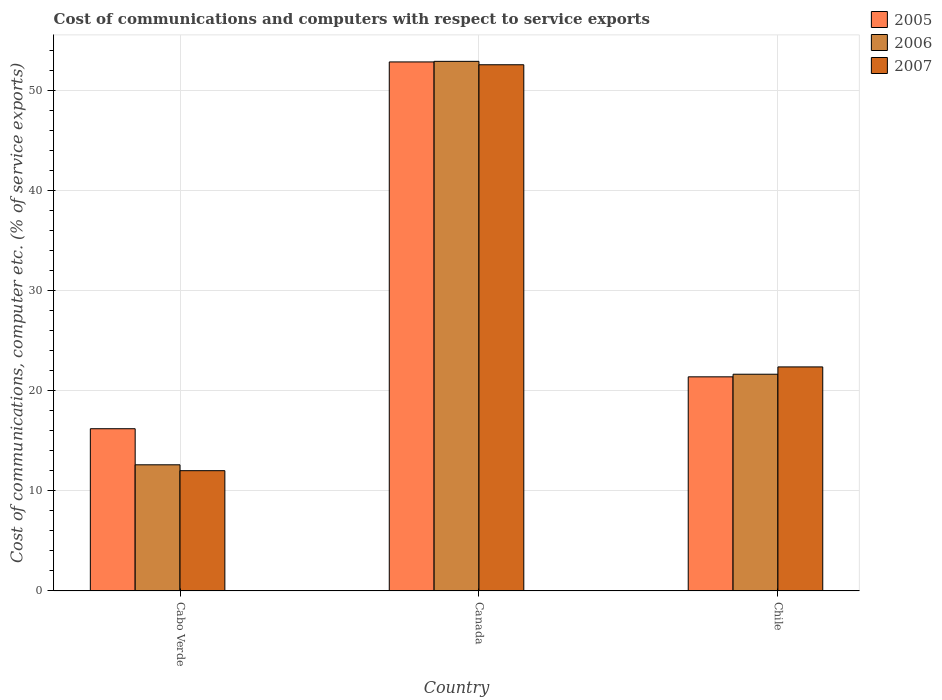How many bars are there on the 2nd tick from the left?
Provide a short and direct response. 3. How many bars are there on the 2nd tick from the right?
Offer a very short reply. 3. What is the cost of communications and computers in 2006 in Cabo Verde?
Provide a succinct answer. 12.61. Across all countries, what is the maximum cost of communications and computers in 2007?
Make the answer very short. 52.62. Across all countries, what is the minimum cost of communications and computers in 2006?
Keep it short and to the point. 12.61. In which country was the cost of communications and computers in 2005 minimum?
Your response must be concise. Cabo Verde. What is the total cost of communications and computers in 2005 in the graph?
Your answer should be compact. 90.53. What is the difference between the cost of communications and computers in 2005 in Cabo Verde and that in Chile?
Make the answer very short. -5.19. What is the difference between the cost of communications and computers in 2006 in Cabo Verde and the cost of communications and computers in 2005 in Canada?
Offer a very short reply. -40.29. What is the average cost of communications and computers in 2007 per country?
Ensure brevity in your answer.  29.01. What is the difference between the cost of communications and computers of/in 2005 and cost of communications and computers of/in 2006 in Chile?
Offer a very short reply. -0.26. What is the ratio of the cost of communications and computers in 2006 in Cabo Verde to that in Canada?
Ensure brevity in your answer.  0.24. Is the cost of communications and computers in 2005 in Cabo Verde less than that in Chile?
Ensure brevity in your answer.  Yes. Is the difference between the cost of communications and computers in 2005 in Cabo Verde and Canada greater than the difference between the cost of communications and computers in 2006 in Cabo Verde and Canada?
Offer a terse response. Yes. What is the difference between the highest and the second highest cost of communications and computers in 2007?
Your answer should be very brief. 40.59. What is the difference between the highest and the lowest cost of communications and computers in 2005?
Ensure brevity in your answer.  36.68. In how many countries, is the cost of communications and computers in 2005 greater than the average cost of communications and computers in 2005 taken over all countries?
Provide a succinct answer. 1. Is the sum of the cost of communications and computers in 2005 in Canada and Chile greater than the maximum cost of communications and computers in 2007 across all countries?
Your answer should be very brief. Yes. What does the 3rd bar from the left in Cabo Verde represents?
Give a very brief answer. 2007. What does the 1st bar from the right in Cabo Verde represents?
Offer a terse response. 2007. How many bars are there?
Provide a short and direct response. 9. What is the difference between two consecutive major ticks on the Y-axis?
Ensure brevity in your answer.  10. Where does the legend appear in the graph?
Make the answer very short. Top right. What is the title of the graph?
Give a very brief answer. Cost of communications and computers with respect to service exports. What is the label or title of the X-axis?
Your answer should be very brief. Country. What is the label or title of the Y-axis?
Your answer should be compact. Cost of communications, computer etc. (% of service exports). What is the Cost of communications, computer etc. (% of service exports) of 2005 in Cabo Verde?
Your answer should be compact. 16.22. What is the Cost of communications, computer etc. (% of service exports) in 2006 in Cabo Verde?
Give a very brief answer. 12.61. What is the Cost of communications, computer etc. (% of service exports) in 2007 in Cabo Verde?
Offer a very short reply. 12.02. What is the Cost of communications, computer etc. (% of service exports) in 2005 in Canada?
Offer a very short reply. 52.9. What is the Cost of communications, computer etc. (% of service exports) in 2006 in Canada?
Keep it short and to the point. 52.96. What is the Cost of communications, computer etc. (% of service exports) of 2007 in Canada?
Your answer should be very brief. 52.62. What is the Cost of communications, computer etc. (% of service exports) of 2005 in Chile?
Give a very brief answer. 21.41. What is the Cost of communications, computer etc. (% of service exports) of 2006 in Chile?
Offer a very short reply. 21.67. What is the Cost of communications, computer etc. (% of service exports) in 2007 in Chile?
Offer a very short reply. 22.4. Across all countries, what is the maximum Cost of communications, computer etc. (% of service exports) of 2005?
Provide a short and direct response. 52.9. Across all countries, what is the maximum Cost of communications, computer etc. (% of service exports) of 2006?
Provide a short and direct response. 52.96. Across all countries, what is the maximum Cost of communications, computer etc. (% of service exports) of 2007?
Keep it short and to the point. 52.62. Across all countries, what is the minimum Cost of communications, computer etc. (% of service exports) in 2005?
Keep it short and to the point. 16.22. Across all countries, what is the minimum Cost of communications, computer etc. (% of service exports) of 2006?
Your answer should be compact. 12.61. Across all countries, what is the minimum Cost of communications, computer etc. (% of service exports) of 2007?
Offer a very short reply. 12.02. What is the total Cost of communications, computer etc. (% of service exports) in 2005 in the graph?
Keep it short and to the point. 90.53. What is the total Cost of communications, computer etc. (% of service exports) of 2006 in the graph?
Offer a very short reply. 87.24. What is the total Cost of communications, computer etc. (% of service exports) of 2007 in the graph?
Make the answer very short. 87.04. What is the difference between the Cost of communications, computer etc. (% of service exports) of 2005 in Cabo Verde and that in Canada?
Your response must be concise. -36.68. What is the difference between the Cost of communications, computer etc. (% of service exports) of 2006 in Cabo Verde and that in Canada?
Offer a very short reply. -40.35. What is the difference between the Cost of communications, computer etc. (% of service exports) of 2007 in Cabo Verde and that in Canada?
Your answer should be very brief. -40.59. What is the difference between the Cost of communications, computer etc. (% of service exports) of 2005 in Cabo Verde and that in Chile?
Make the answer very short. -5.19. What is the difference between the Cost of communications, computer etc. (% of service exports) in 2006 in Cabo Verde and that in Chile?
Make the answer very short. -9.06. What is the difference between the Cost of communications, computer etc. (% of service exports) in 2007 in Cabo Verde and that in Chile?
Provide a short and direct response. -10.38. What is the difference between the Cost of communications, computer etc. (% of service exports) of 2005 in Canada and that in Chile?
Your answer should be compact. 31.49. What is the difference between the Cost of communications, computer etc. (% of service exports) in 2006 in Canada and that in Chile?
Ensure brevity in your answer.  31.29. What is the difference between the Cost of communications, computer etc. (% of service exports) of 2007 in Canada and that in Chile?
Your response must be concise. 30.22. What is the difference between the Cost of communications, computer etc. (% of service exports) of 2005 in Cabo Verde and the Cost of communications, computer etc. (% of service exports) of 2006 in Canada?
Provide a short and direct response. -36.74. What is the difference between the Cost of communications, computer etc. (% of service exports) in 2005 in Cabo Verde and the Cost of communications, computer etc. (% of service exports) in 2007 in Canada?
Offer a terse response. -36.4. What is the difference between the Cost of communications, computer etc. (% of service exports) in 2006 in Cabo Verde and the Cost of communications, computer etc. (% of service exports) in 2007 in Canada?
Offer a terse response. -40. What is the difference between the Cost of communications, computer etc. (% of service exports) in 2005 in Cabo Verde and the Cost of communications, computer etc. (% of service exports) in 2006 in Chile?
Provide a succinct answer. -5.45. What is the difference between the Cost of communications, computer etc. (% of service exports) in 2005 in Cabo Verde and the Cost of communications, computer etc. (% of service exports) in 2007 in Chile?
Your answer should be very brief. -6.18. What is the difference between the Cost of communications, computer etc. (% of service exports) of 2006 in Cabo Verde and the Cost of communications, computer etc. (% of service exports) of 2007 in Chile?
Make the answer very short. -9.79. What is the difference between the Cost of communications, computer etc. (% of service exports) in 2005 in Canada and the Cost of communications, computer etc. (% of service exports) in 2006 in Chile?
Your response must be concise. 31.23. What is the difference between the Cost of communications, computer etc. (% of service exports) of 2005 in Canada and the Cost of communications, computer etc. (% of service exports) of 2007 in Chile?
Your response must be concise. 30.5. What is the difference between the Cost of communications, computer etc. (% of service exports) in 2006 in Canada and the Cost of communications, computer etc. (% of service exports) in 2007 in Chile?
Give a very brief answer. 30.56. What is the average Cost of communications, computer etc. (% of service exports) in 2005 per country?
Ensure brevity in your answer.  30.18. What is the average Cost of communications, computer etc. (% of service exports) in 2006 per country?
Offer a terse response. 29.08. What is the average Cost of communications, computer etc. (% of service exports) in 2007 per country?
Offer a very short reply. 29.01. What is the difference between the Cost of communications, computer etc. (% of service exports) of 2005 and Cost of communications, computer etc. (% of service exports) of 2006 in Cabo Verde?
Your answer should be compact. 3.61. What is the difference between the Cost of communications, computer etc. (% of service exports) of 2005 and Cost of communications, computer etc. (% of service exports) of 2007 in Cabo Verde?
Provide a succinct answer. 4.19. What is the difference between the Cost of communications, computer etc. (% of service exports) of 2006 and Cost of communications, computer etc. (% of service exports) of 2007 in Cabo Verde?
Offer a very short reply. 0.59. What is the difference between the Cost of communications, computer etc. (% of service exports) of 2005 and Cost of communications, computer etc. (% of service exports) of 2006 in Canada?
Provide a short and direct response. -0.06. What is the difference between the Cost of communications, computer etc. (% of service exports) of 2005 and Cost of communications, computer etc. (% of service exports) of 2007 in Canada?
Keep it short and to the point. 0.28. What is the difference between the Cost of communications, computer etc. (% of service exports) in 2006 and Cost of communications, computer etc. (% of service exports) in 2007 in Canada?
Give a very brief answer. 0.34. What is the difference between the Cost of communications, computer etc. (% of service exports) of 2005 and Cost of communications, computer etc. (% of service exports) of 2006 in Chile?
Make the answer very short. -0.26. What is the difference between the Cost of communications, computer etc. (% of service exports) of 2005 and Cost of communications, computer etc. (% of service exports) of 2007 in Chile?
Ensure brevity in your answer.  -0.99. What is the difference between the Cost of communications, computer etc. (% of service exports) in 2006 and Cost of communications, computer etc. (% of service exports) in 2007 in Chile?
Keep it short and to the point. -0.73. What is the ratio of the Cost of communications, computer etc. (% of service exports) in 2005 in Cabo Verde to that in Canada?
Offer a terse response. 0.31. What is the ratio of the Cost of communications, computer etc. (% of service exports) of 2006 in Cabo Verde to that in Canada?
Provide a short and direct response. 0.24. What is the ratio of the Cost of communications, computer etc. (% of service exports) in 2007 in Cabo Verde to that in Canada?
Offer a very short reply. 0.23. What is the ratio of the Cost of communications, computer etc. (% of service exports) of 2005 in Cabo Verde to that in Chile?
Give a very brief answer. 0.76. What is the ratio of the Cost of communications, computer etc. (% of service exports) of 2006 in Cabo Verde to that in Chile?
Ensure brevity in your answer.  0.58. What is the ratio of the Cost of communications, computer etc. (% of service exports) of 2007 in Cabo Verde to that in Chile?
Your answer should be very brief. 0.54. What is the ratio of the Cost of communications, computer etc. (% of service exports) in 2005 in Canada to that in Chile?
Your answer should be compact. 2.47. What is the ratio of the Cost of communications, computer etc. (% of service exports) in 2006 in Canada to that in Chile?
Offer a very short reply. 2.44. What is the ratio of the Cost of communications, computer etc. (% of service exports) of 2007 in Canada to that in Chile?
Make the answer very short. 2.35. What is the difference between the highest and the second highest Cost of communications, computer etc. (% of service exports) of 2005?
Give a very brief answer. 31.49. What is the difference between the highest and the second highest Cost of communications, computer etc. (% of service exports) of 2006?
Your answer should be compact. 31.29. What is the difference between the highest and the second highest Cost of communications, computer etc. (% of service exports) in 2007?
Your answer should be very brief. 30.22. What is the difference between the highest and the lowest Cost of communications, computer etc. (% of service exports) of 2005?
Your answer should be compact. 36.68. What is the difference between the highest and the lowest Cost of communications, computer etc. (% of service exports) in 2006?
Provide a short and direct response. 40.35. What is the difference between the highest and the lowest Cost of communications, computer etc. (% of service exports) in 2007?
Keep it short and to the point. 40.59. 